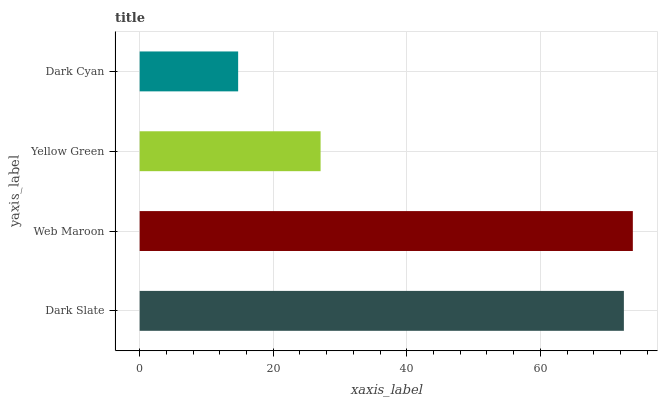Is Dark Cyan the minimum?
Answer yes or no. Yes. Is Web Maroon the maximum?
Answer yes or no. Yes. Is Yellow Green the minimum?
Answer yes or no. No. Is Yellow Green the maximum?
Answer yes or no. No. Is Web Maroon greater than Yellow Green?
Answer yes or no. Yes. Is Yellow Green less than Web Maroon?
Answer yes or no. Yes. Is Yellow Green greater than Web Maroon?
Answer yes or no. No. Is Web Maroon less than Yellow Green?
Answer yes or no. No. Is Dark Slate the high median?
Answer yes or no. Yes. Is Yellow Green the low median?
Answer yes or no. Yes. Is Dark Cyan the high median?
Answer yes or no. No. Is Web Maroon the low median?
Answer yes or no. No. 